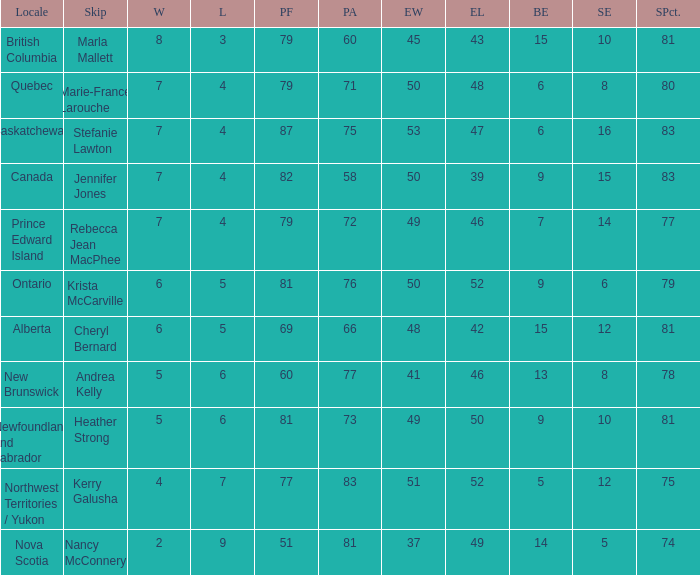What is the pf for Rebecca Jean Macphee? 79.0. Would you mind parsing the complete table? {'header': ['Locale', 'Skip', 'W', 'L', 'PF', 'PA', 'EW', 'EL', 'BE', 'SE', 'SPct.'], 'rows': [['British Columbia', 'Marla Mallett', '8', '3', '79', '60', '45', '43', '15', '10', '81'], ['Quebec', 'Marie-France Larouche', '7', '4', '79', '71', '50', '48', '6', '8', '80'], ['Saskatchewan', 'Stefanie Lawton', '7', '4', '87', '75', '53', '47', '6', '16', '83'], ['Canada', 'Jennifer Jones', '7', '4', '82', '58', '50', '39', '9', '15', '83'], ['Prince Edward Island', 'Rebecca Jean MacPhee', '7', '4', '79', '72', '49', '46', '7', '14', '77'], ['Ontario', 'Krista McCarville', '6', '5', '81', '76', '50', '52', '9', '6', '79'], ['Alberta', 'Cheryl Bernard', '6', '5', '69', '66', '48', '42', '15', '12', '81'], ['New Brunswick', 'Andrea Kelly', '5', '6', '60', '77', '41', '46', '13', '8', '78'], ['Newfoundland and Labrador', 'Heather Strong', '5', '6', '81', '73', '49', '50', '9', '10', '81'], ['Northwest Territories / Yukon', 'Kerry Galusha', '4', '7', '77', '83', '51', '52', '5', '12', '75'], ['Nova Scotia', 'Nancy McConnery', '2', '9', '51', '81', '37', '49', '14', '5', '74']]} 